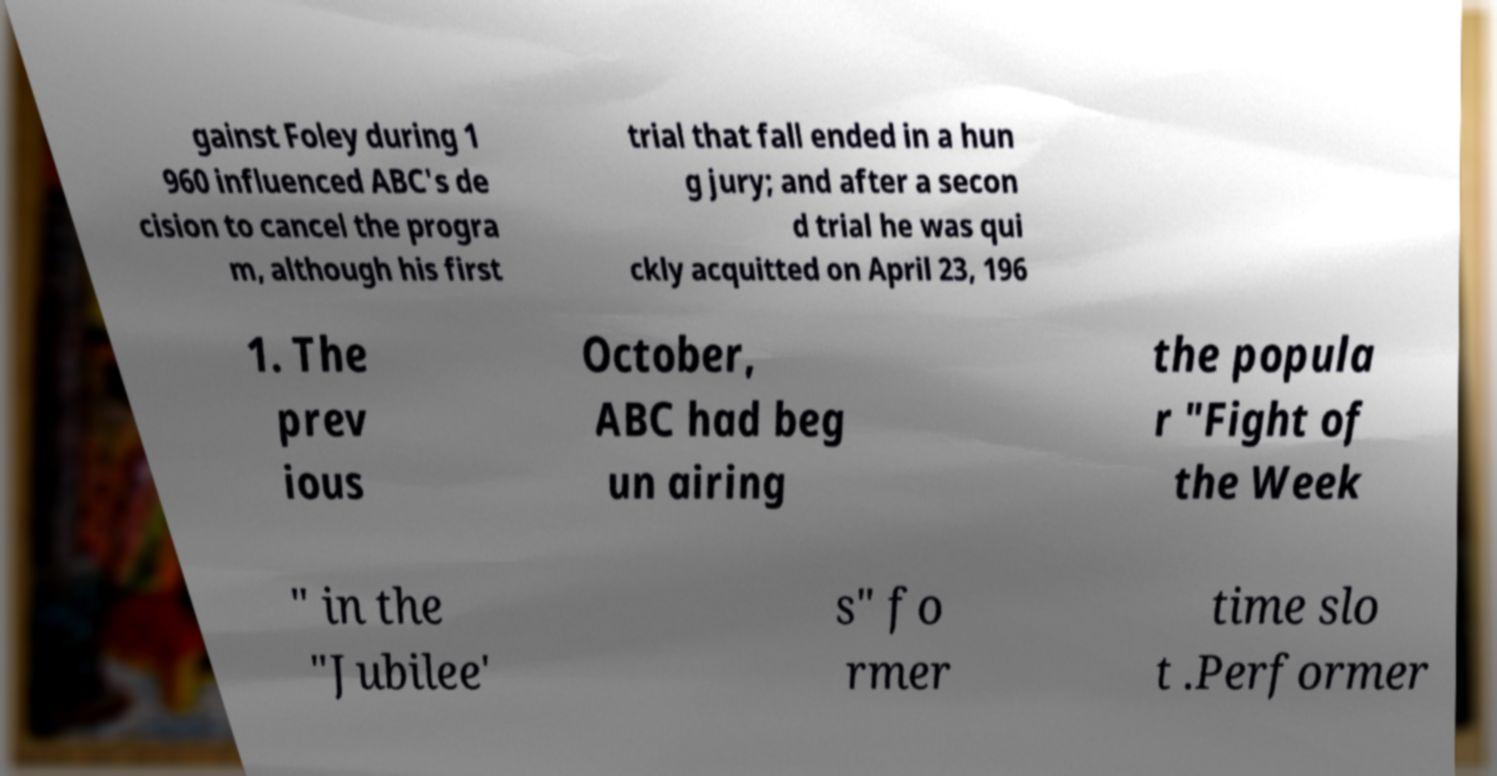Can you read and provide the text displayed in the image?This photo seems to have some interesting text. Can you extract and type it out for me? gainst Foley during 1 960 influenced ABC's de cision to cancel the progra m, although his first trial that fall ended in a hun g jury; and after a secon d trial he was qui ckly acquitted on April 23, 196 1. The prev ious October, ABC had beg un airing the popula r "Fight of the Week " in the "Jubilee' s" fo rmer time slo t .Performer 